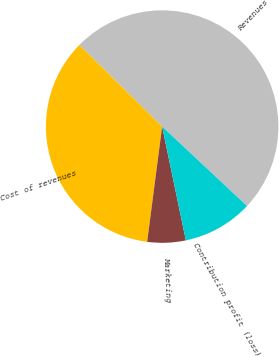Convert chart. <chart><loc_0><loc_0><loc_500><loc_500><pie_chart><fcel>Revenues<fcel>Cost of revenues<fcel>Marketing<fcel>Contribution profit (loss)<nl><fcel>49.59%<fcel>35.33%<fcel>5.33%<fcel>9.75%<nl></chart> 